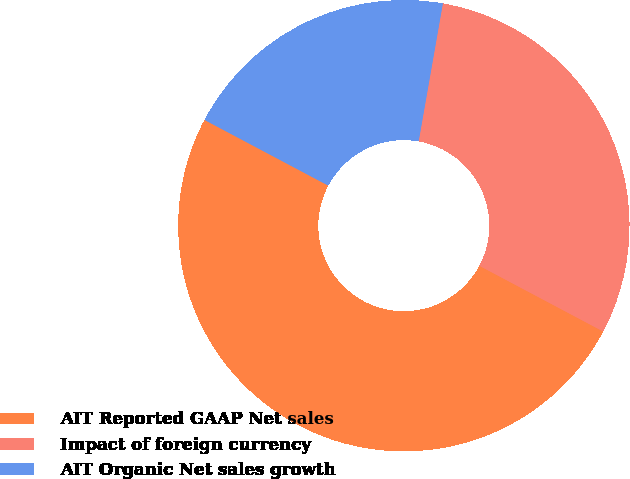<chart> <loc_0><loc_0><loc_500><loc_500><pie_chart><fcel>AIT Reported GAAP Net sales<fcel>Impact of foreign currency<fcel>AIT Organic Net sales growth<nl><fcel>50.0%<fcel>30.0%<fcel>20.0%<nl></chart> 